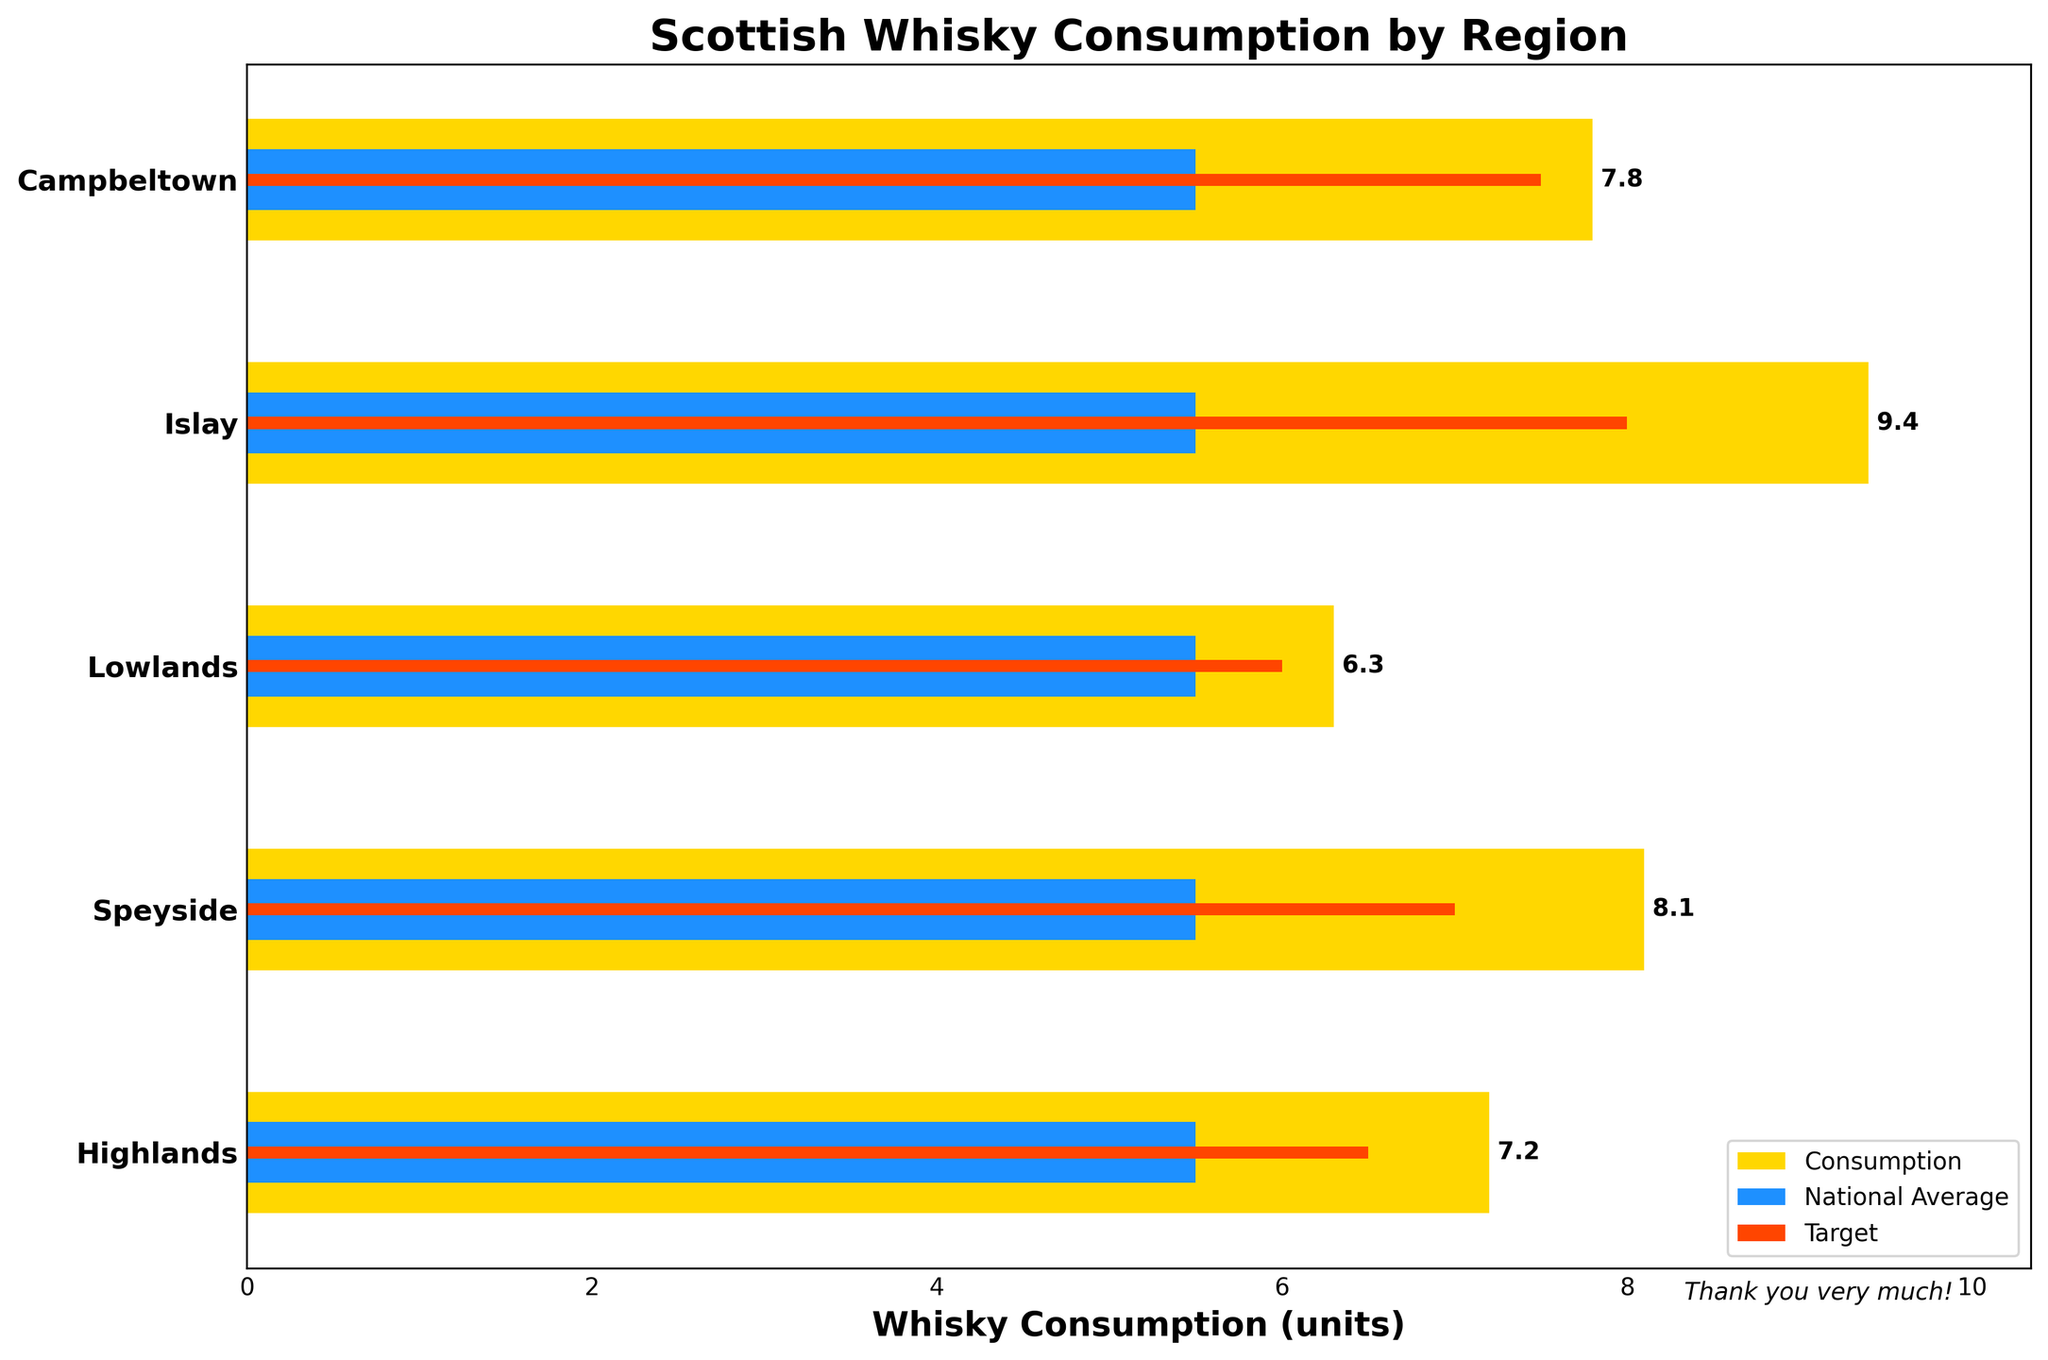What's the title of the chart? The title is at the top of the figure, prominently displayed in a larger font and bold. It provides a concise summary of what the chart represents.
Answer: Scottish Whisky Consumption by Region Which region has the highest whisky consumption? Examine the lengths of the yellow bars representing consumption for all regions. Identify the region with the longest yellow bar.
Answer: Islay How does the national average compare to the overall targets? Compare the lengths of the blue bars (national average) and the red bars (targets).
Answer: The national average (all blue bars) is below the targets (all red bars) in all regions What is the average consumption value for all regions? Sum the consumption values of all regions and divide by the number of regions: (7.2 + 8.1 + 6.3 + 9.4 + 7.8) / 5
Answer: 7.76 Which regions have consumption values above their targets? Compare the end position of the yellow bars (consumption) with the red bars (targets) for all regions to identify those where the yellow bar is longer.
Answer: Islay, Campbeltown How much higher is Islay's consumption compared to the national average? Subtract the national average from Islay's consumption: 9.4 - 5.5
Answer: 3.9 Which region's consumption is closest to the national average? Find the region with a consumption value closest to the national average of 5.5 by calculating the absolute differences:
Answer: Lowlands (0.8) Are there any regions where consumption exactly matches the target? Compare the lengths of the yellow bars (consumption) with the red bars (targets) for all regions to see if any are equal.
Answer: None What color represents the national average in the plot? Look at the legend in the chart, where each bar is labeled with its corresponding color and category.
Answer: Blue 